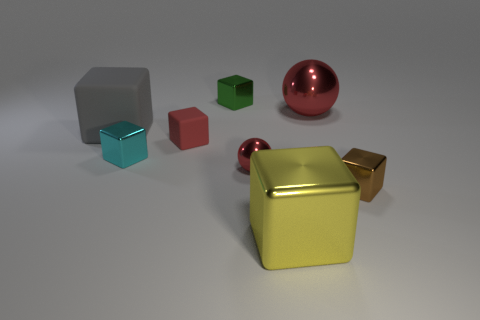There is a small cyan object that is the same material as the tiny green object; what is its shape?
Your answer should be very brief. Cube. How many other things are the same shape as the red rubber object?
Ensure brevity in your answer.  5. How many small metallic blocks are to the left of the large red metallic object?
Keep it short and to the point. 2. Is the size of the red thing on the left side of the green shiny object the same as the metal ball that is to the left of the large yellow thing?
Provide a succinct answer. Yes. How many other objects are there of the same size as the cyan block?
Your answer should be very brief. 4. There is a large cube to the left of the rubber cube that is in front of the matte object that is behind the red matte block; what is it made of?
Offer a very short reply. Rubber. There is a yellow shiny cube; is its size the same as the red object that is in front of the small cyan object?
Provide a succinct answer. No. What is the size of the block that is both behind the large yellow object and in front of the small red sphere?
Ensure brevity in your answer.  Small. Is there a shiny sphere that has the same color as the small rubber object?
Your response must be concise. Yes. The large block behind the rubber thing that is in front of the large matte object is what color?
Your answer should be very brief. Gray. 